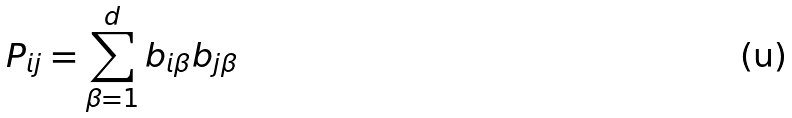<formula> <loc_0><loc_0><loc_500><loc_500>P _ { i j } = \sum _ { \beta = 1 } ^ { d } b _ { i \beta } b _ { j \beta }</formula> 